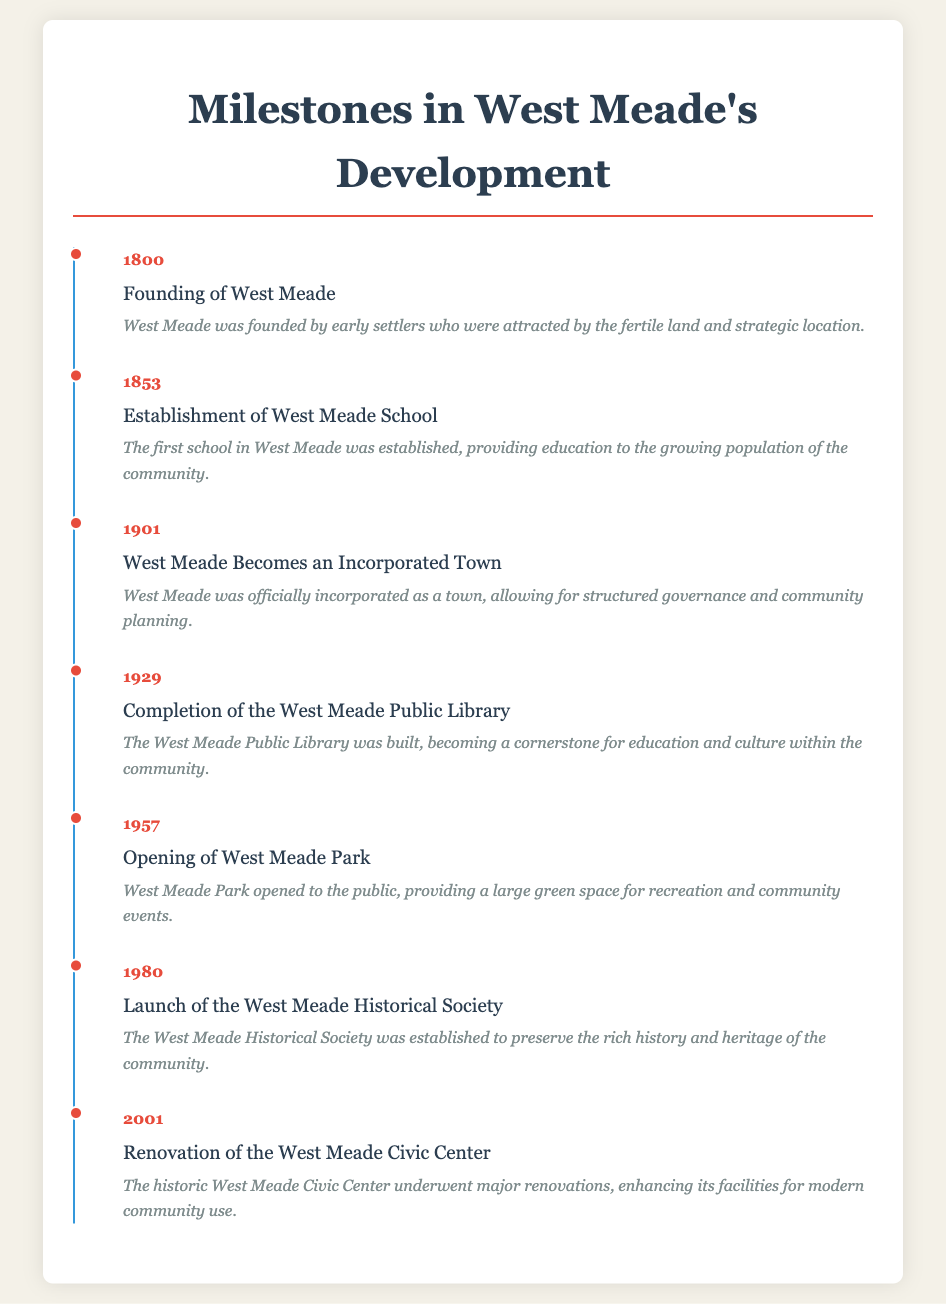What year was West Meade founded? The document states that West Meade was founded in the year 1800.
Answer: 1800 What significant development occurred in 1853? In 1853, the first school in West Meade was established.
Answer: Establishment of West Meade School When did West Meade become an incorporated town? According to the timeline, West Meade officially became an incorporated town in 1901.
Answer: 1901 What was completed in 1929? The timeline indicates that the West Meade Public Library was completed in 1929.
Answer: Completion of the West Meade Public Library What community resource opened in 1957? In 1957, West Meade Park opened to the public.
Answer: Opening of West Meade Park What organization was launched in 1980? The document states that the West Meade Historical Society was established in 1980.
Answer: Launch of the West Meade Historical Society What year did the West Meade Civic Center undergo renovations? The renovation of the West Meade Civic Center took place in 2001.
Answer: 2001 What event marks the first educational institution in West Meade? The establishment of the West Meade School is noted as the first educational institution.
Answer: Establishment of West Meade School How many significant moments are detailed in the document? The document details seven significant moments in West Meade's development.
Answer: Seven 